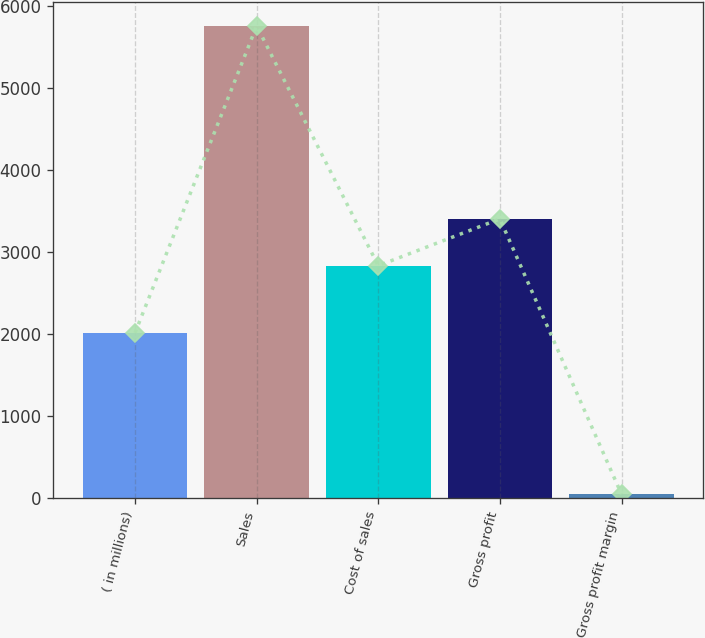Convert chart to OTSL. <chart><loc_0><loc_0><loc_500><loc_500><bar_chart><fcel>( in millions)<fcel>Sales<fcel>Cost of sales<fcel>Gross profit<fcel>Gross profit margin<nl><fcel>2017<fcel>5756.1<fcel>2834.7<fcel>3405.23<fcel>50.8<nl></chart> 